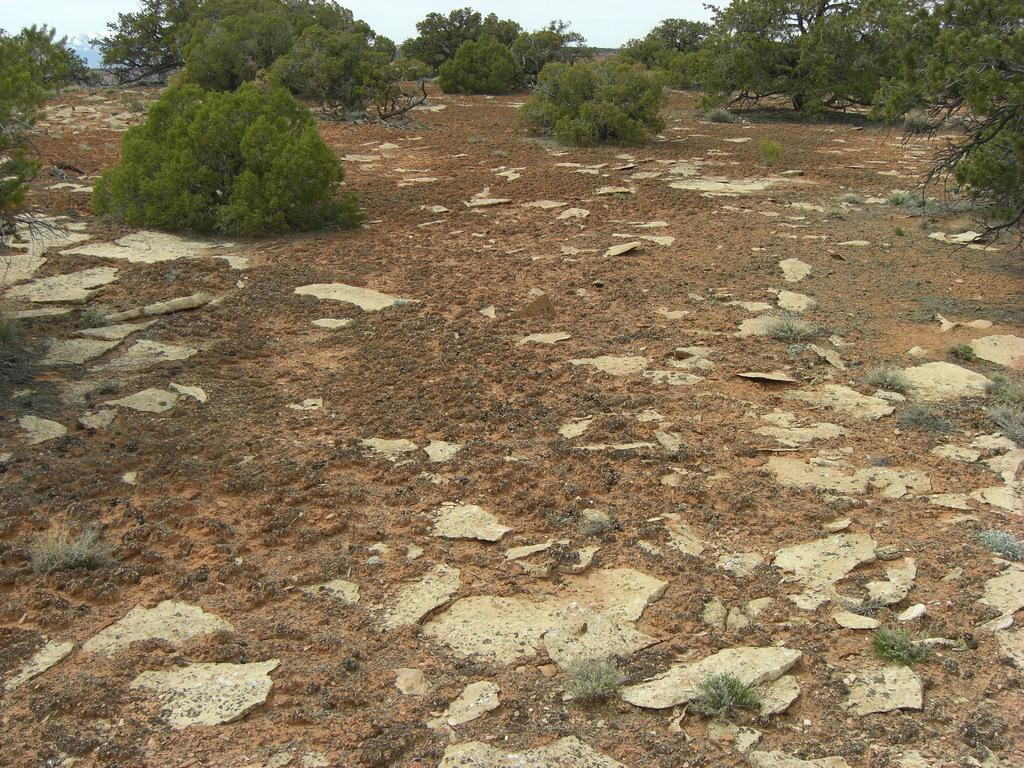What type of vegetation can be seen in the image? There are trees in the image. What is the color of the trees? The trees are green in color. What else is visible in the image besides the trees? There is a sky in the image. What is the color of the sky? The sky is white in color. How many ants can be seen crawling on the trees in the image? There are no ants visible in the image; it only features trees and a sky. Is the image depicting a night scene? The image does not indicate a night scene, as the sky is white in color, which suggests daytime. 